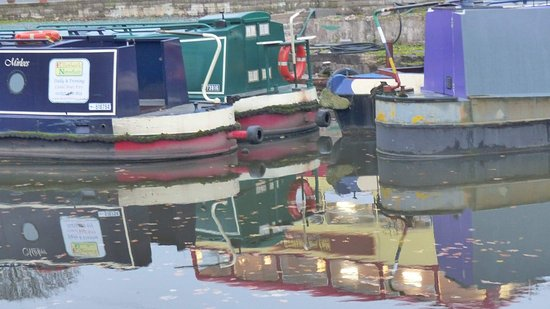Can you describe the reflections in the water? Certainly. The water acts as a mirror, creating a serene and slightly blurred reflection of the boats and their colors. The ripples slightly distort the images, adding a dreamy, Impressionist quality to the scene. How could the reflections help determine the water's condition? The clarity and extent of the reflections hint at calm water with minimal wind disruption. If we were to see more choppy waters, the reflections would be more fragmented and less coherent. 